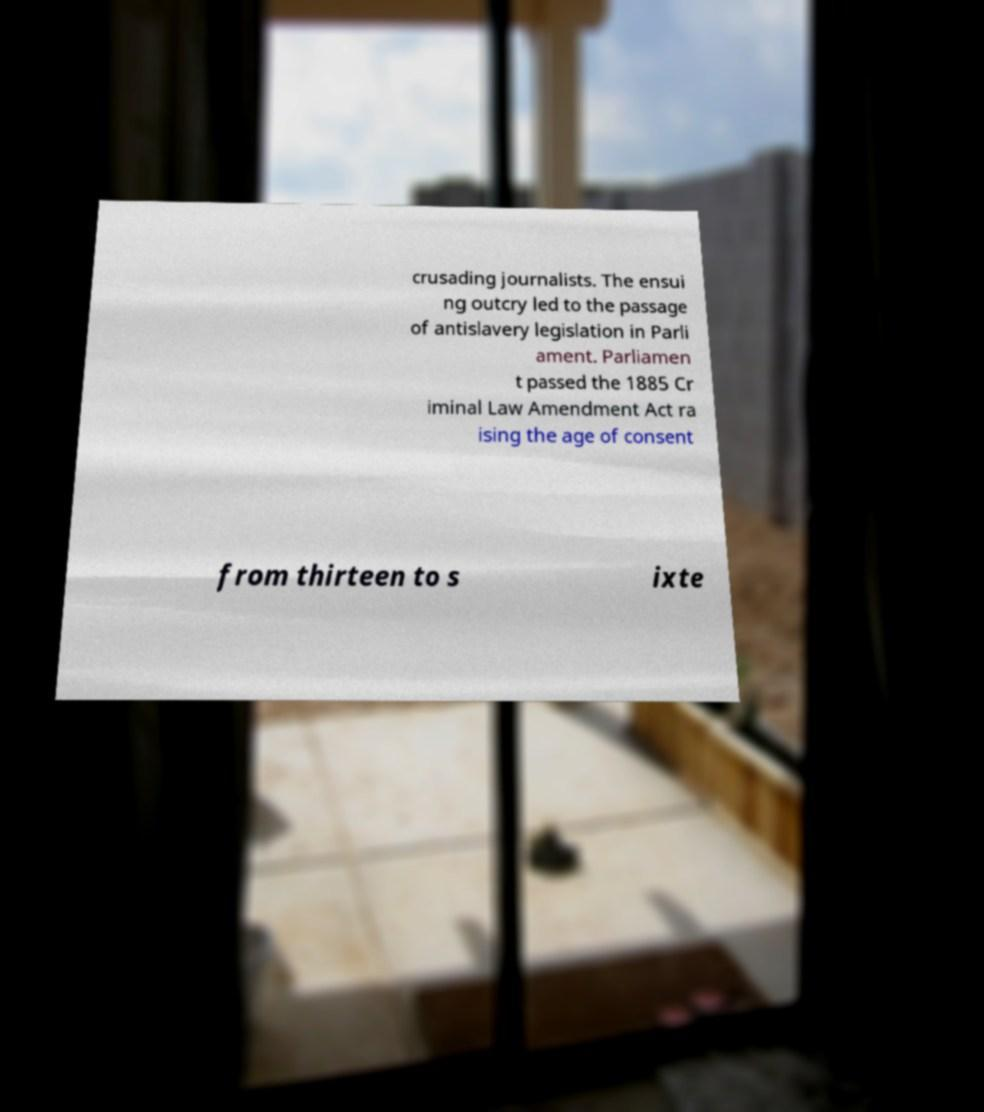Could you extract and type out the text from this image? crusading journalists. The ensui ng outcry led to the passage of antislavery legislation in Parli ament. Parliamen t passed the 1885 Cr iminal Law Amendment Act ra ising the age of consent from thirteen to s ixte 